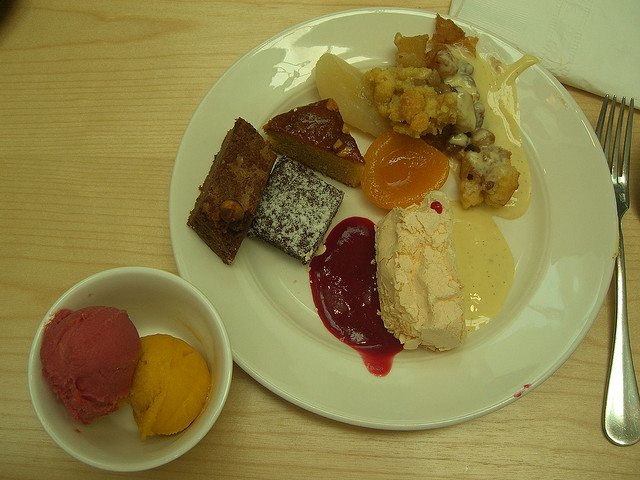<image>What color is the raspberries? I am not sure about the color of the raspberries. It could be red or pink. What color is the raspberries? The raspberries in the image are red. 